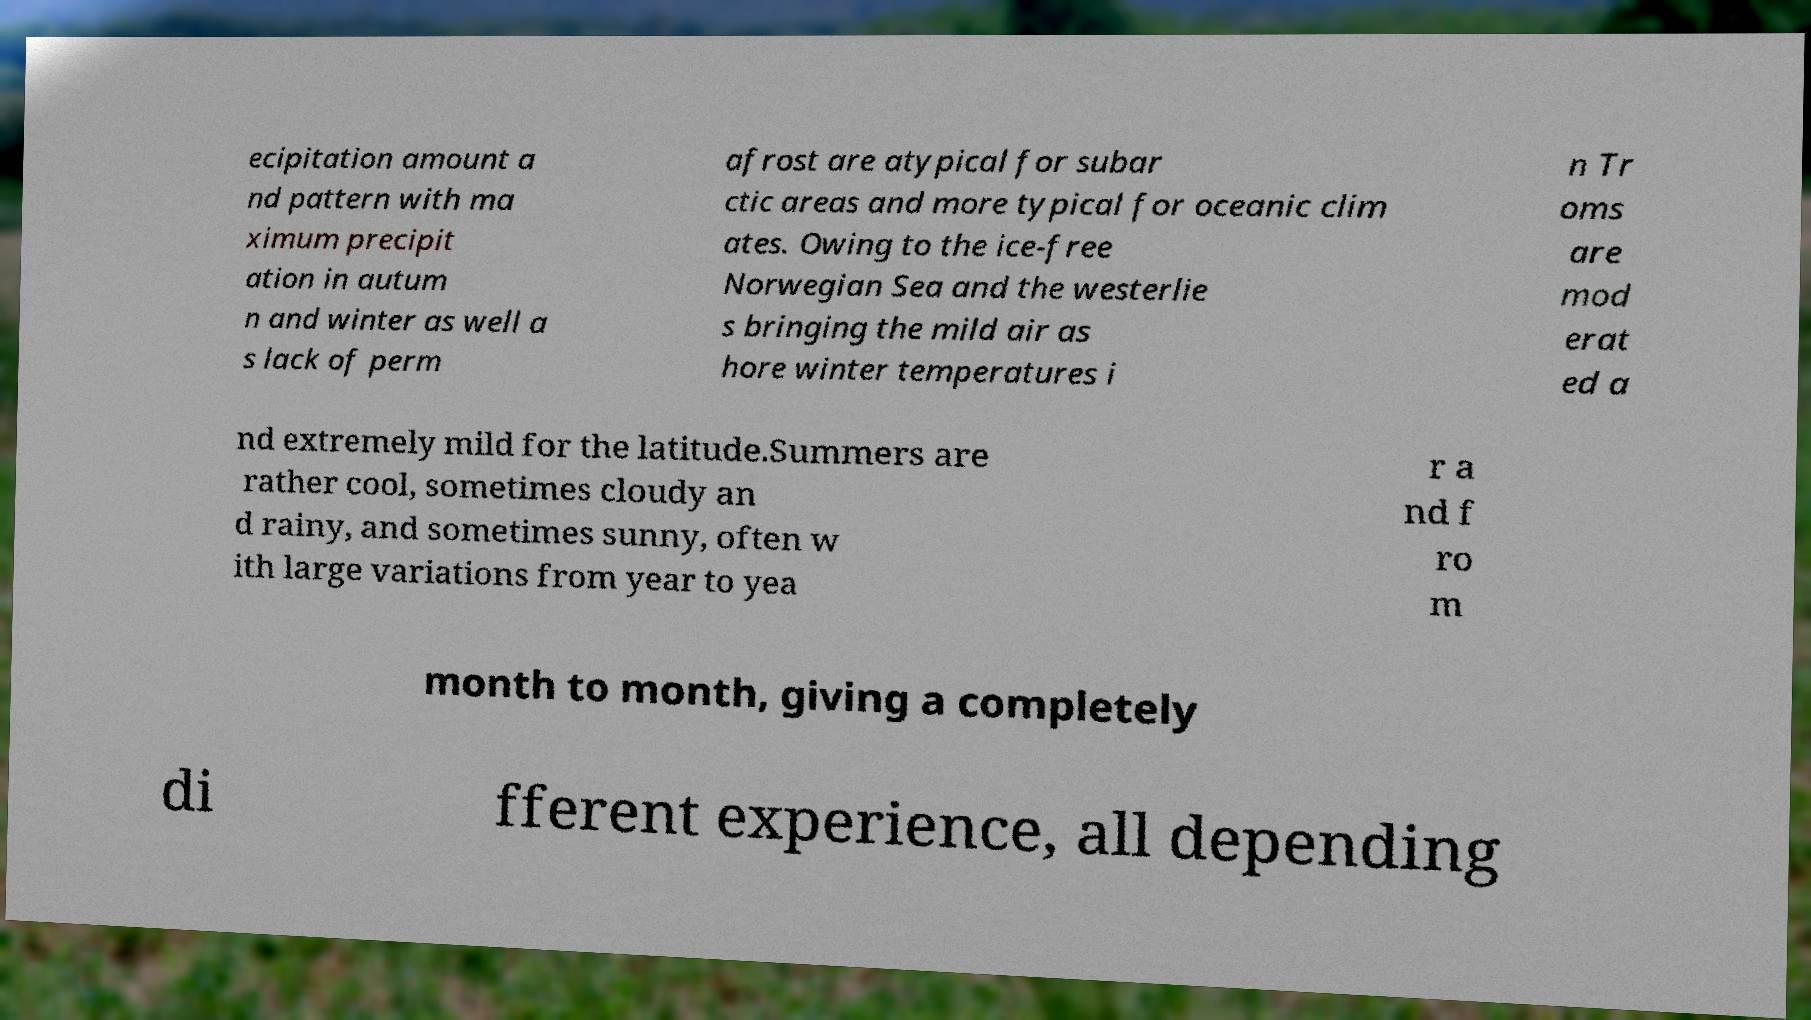Can you accurately transcribe the text from the provided image for me? ecipitation amount a nd pattern with ma ximum precipit ation in autum n and winter as well a s lack of perm afrost are atypical for subar ctic areas and more typical for oceanic clim ates. Owing to the ice-free Norwegian Sea and the westerlie s bringing the mild air as hore winter temperatures i n Tr oms are mod erat ed a nd extremely mild for the latitude.Summers are rather cool, sometimes cloudy an d rainy, and sometimes sunny, often w ith large variations from year to yea r a nd f ro m month to month, giving a completely di fferent experience, all depending 